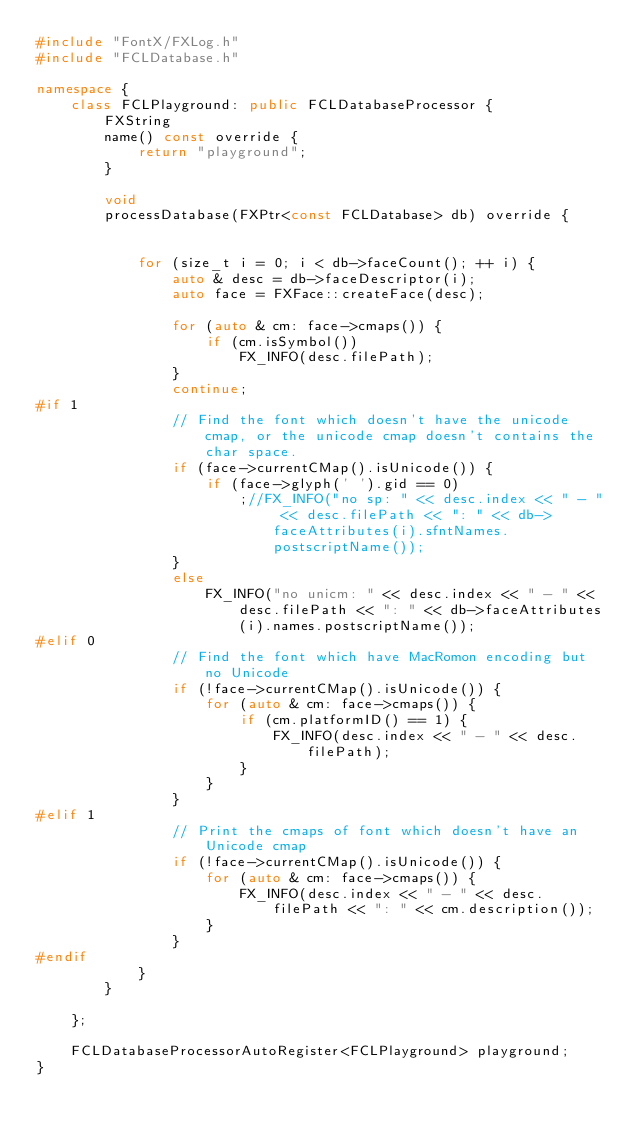<code> <loc_0><loc_0><loc_500><loc_500><_C++_>#include "FontX/FXLog.h"
#include "FCLDatabase.h"

namespace {
    class FCLPlayground: public FCLDatabaseProcessor {
        FXString
        name() const override {
            return "playground";
        }

        void
        processDatabase(FXPtr<const FCLDatabase> db) override {
            
            
            for (size_t i = 0; i < db->faceCount(); ++ i) {
                auto & desc = db->faceDescriptor(i);
                auto face = FXFace::createFace(desc);
                
                for (auto & cm: face->cmaps()) {
                    if (cm.isSymbol())
                        FX_INFO(desc.filePath);
                }
                continue;
#if 1
                // Find the font which doesn't have the unicode cmap, or the unicode cmap doesn't contains the char space.
                if (face->currentCMap().isUnicode()) {
                    if (face->glyph(' ').gid == 0)
                        ;//FX_INFO("no sp: " << desc.index << " - " << desc.filePath << ": " << db->faceAttributes(i).sfntNames.postscriptName());
                }
                else
                    FX_INFO("no unicm: " << desc.index << " - " << desc.filePath << ": " << db->faceAttributes(i).names.postscriptName());
#elif 0
                // Find the font which have MacRomon encoding but no Unicode
                if (!face->currentCMap().isUnicode()) {
                    for (auto & cm: face->cmaps()) {
                        if (cm.platformID() == 1) {
                            FX_INFO(desc.index << " - " << desc.filePath);
                        }
                    }
                }
#elif 1
                // Print the cmaps of font which doesn't have an Unicode cmap
                if (!face->currentCMap().isUnicode()) {
                    for (auto & cm: face->cmaps()) {
                        FX_INFO(desc.index << " - " << desc.filePath << ": " << cm.description());
                    }
                }
#endif
            }
        }

    };

    FCLDatabaseProcessorAutoRegister<FCLPlayground> playground;
}
</code> 